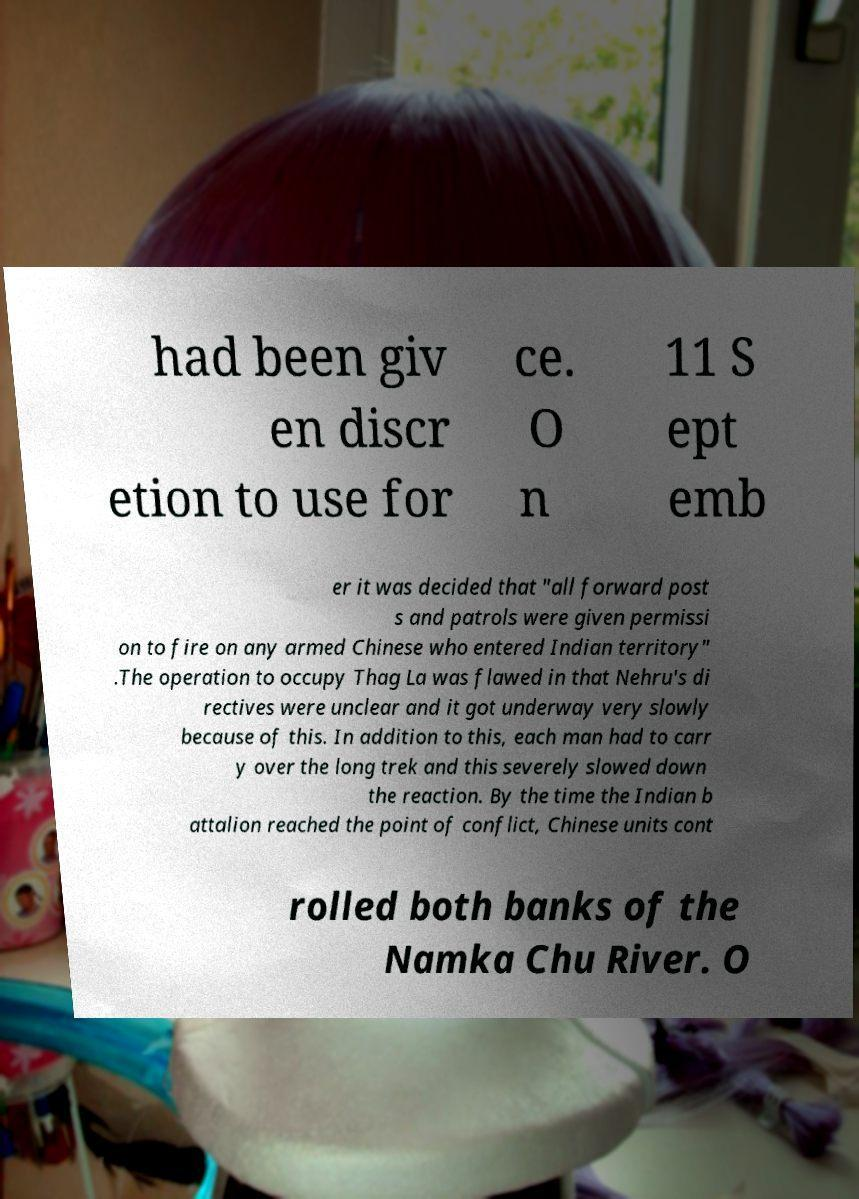Please read and relay the text visible in this image. What does it say? had been giv en discr etion to use for ce. O n 11 S ept emb er it was decided that "all forward post s and patrols were given permissi on to fire on any armed Chinese who entered Indian territory" .The operation to occupy Thag La was flawed in that Nehru's di rectives were unclear and it got underway very slowly because of this. In addition to this, each man had to carr y over the long trek and this severely slowed down the reaction. By the time the Indian b attalion reached the point of conflict, Chinese units cont rolled both banks of the Namka Chu River. O 